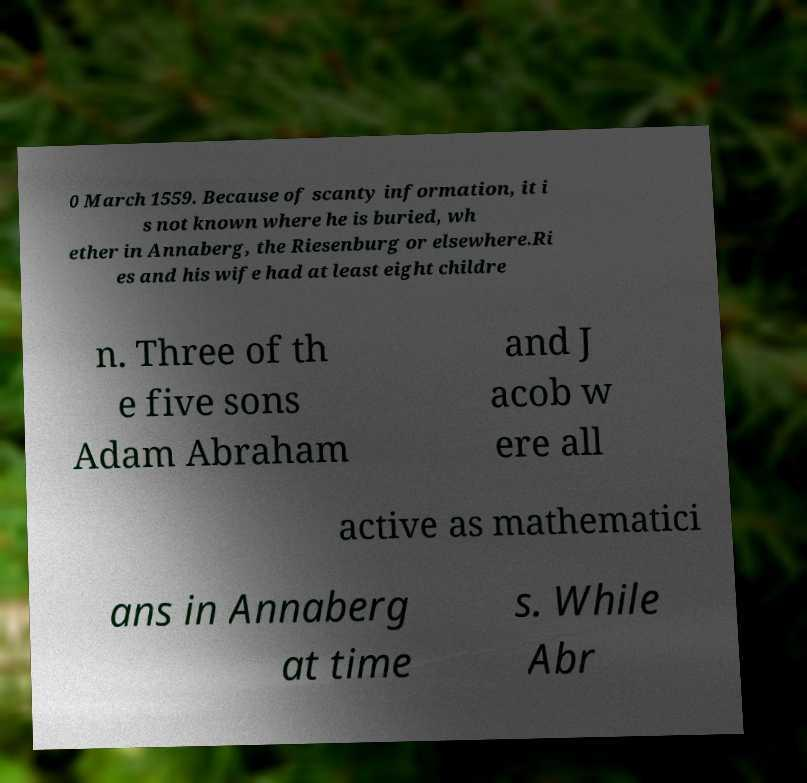What messages or text are displayed in this image? I need them in a readable, typed format. 0 March 1559. Because of scanty information, it i s not known where he is buried, wh ether in Annaberg, the Riesenburg or elsewhere.Ri es and his wife had at least eight childre n. Three of th e five sons Adam Abraham and J acob w ere all active as mathematici ans in Annaberg at time s. While Abr 